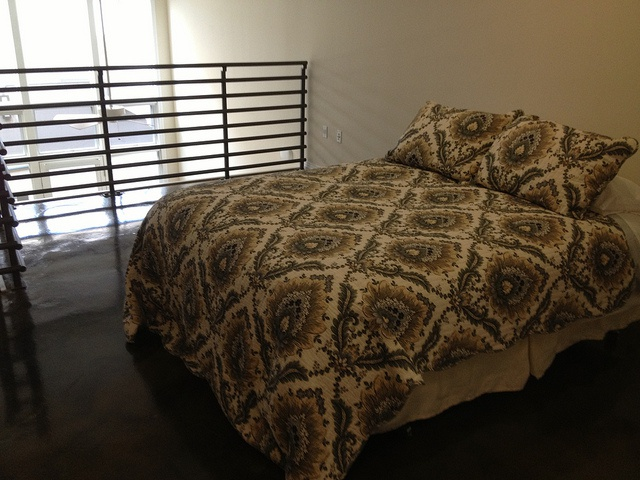Describe the objects in this image and their specific colors. I can see a bed in white, black, and gray tones in this image. 